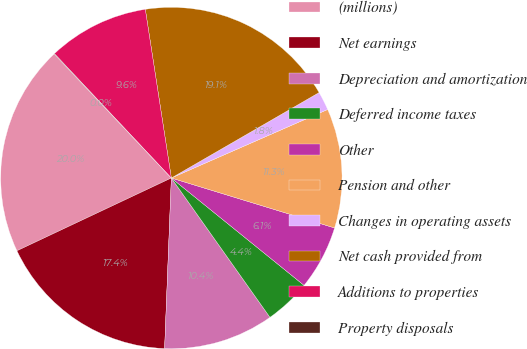Convert chart to OTSL. <chart><loc_0><loc_0><loc_500><loc_500><pie_chart><fcel>(millions)<fcel>Net earnings<fcel>Depreciation and amortization<fcel>Deferred income taxes<fcel>Other<fcel>Pension and other<fcel>Changes in operating assets<fcel>Net cash provided from<fcel>Additions to properties<fcel>Property disposals<nl><fcel>19.96%<fcel>17.36%<fcel>10.43%<fcel>4.37%<fcel>6.1%<fcel>11.3%<fcel>1.77%<fcel>19.09%<fcel>9.57%<fcel>0.04%<nl></chart> 